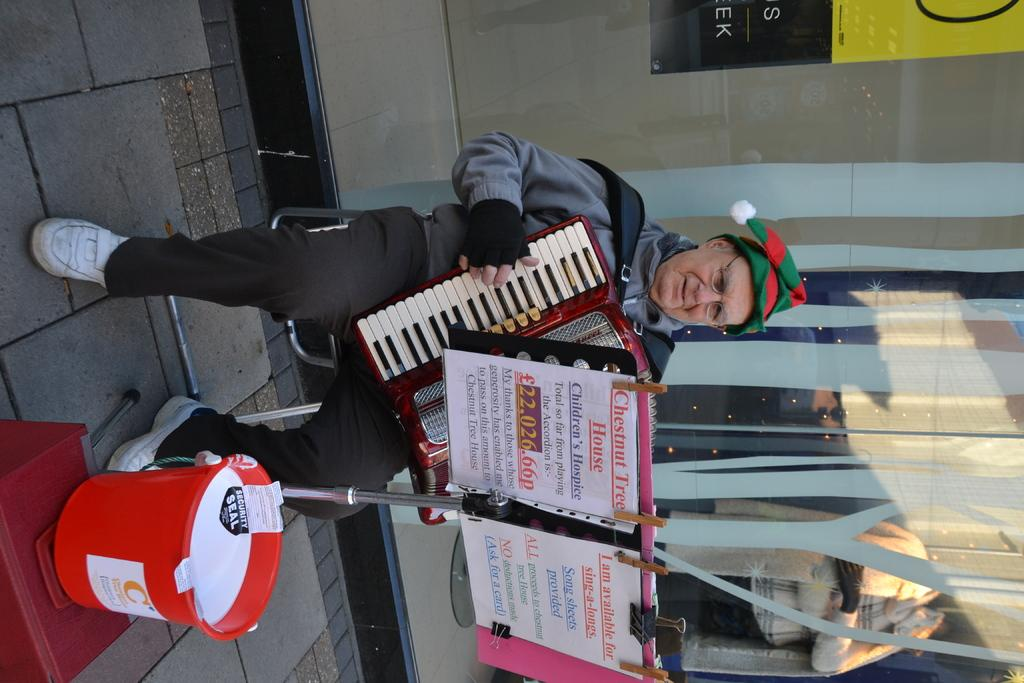What is the man in the image doing? The man is sitting on a chair and playing a musical keyboard with his hand. What object can be seen near the man? There is a bucket in the image. What type of decorations are present in the image? There are posters in the image. What can be seen in the background of the image? There is a mannequin and a banner in the background of the image. How many friends does the man have in the image? The image does not show any friends with the man, so it is not possible to determine the number of friends he has. 